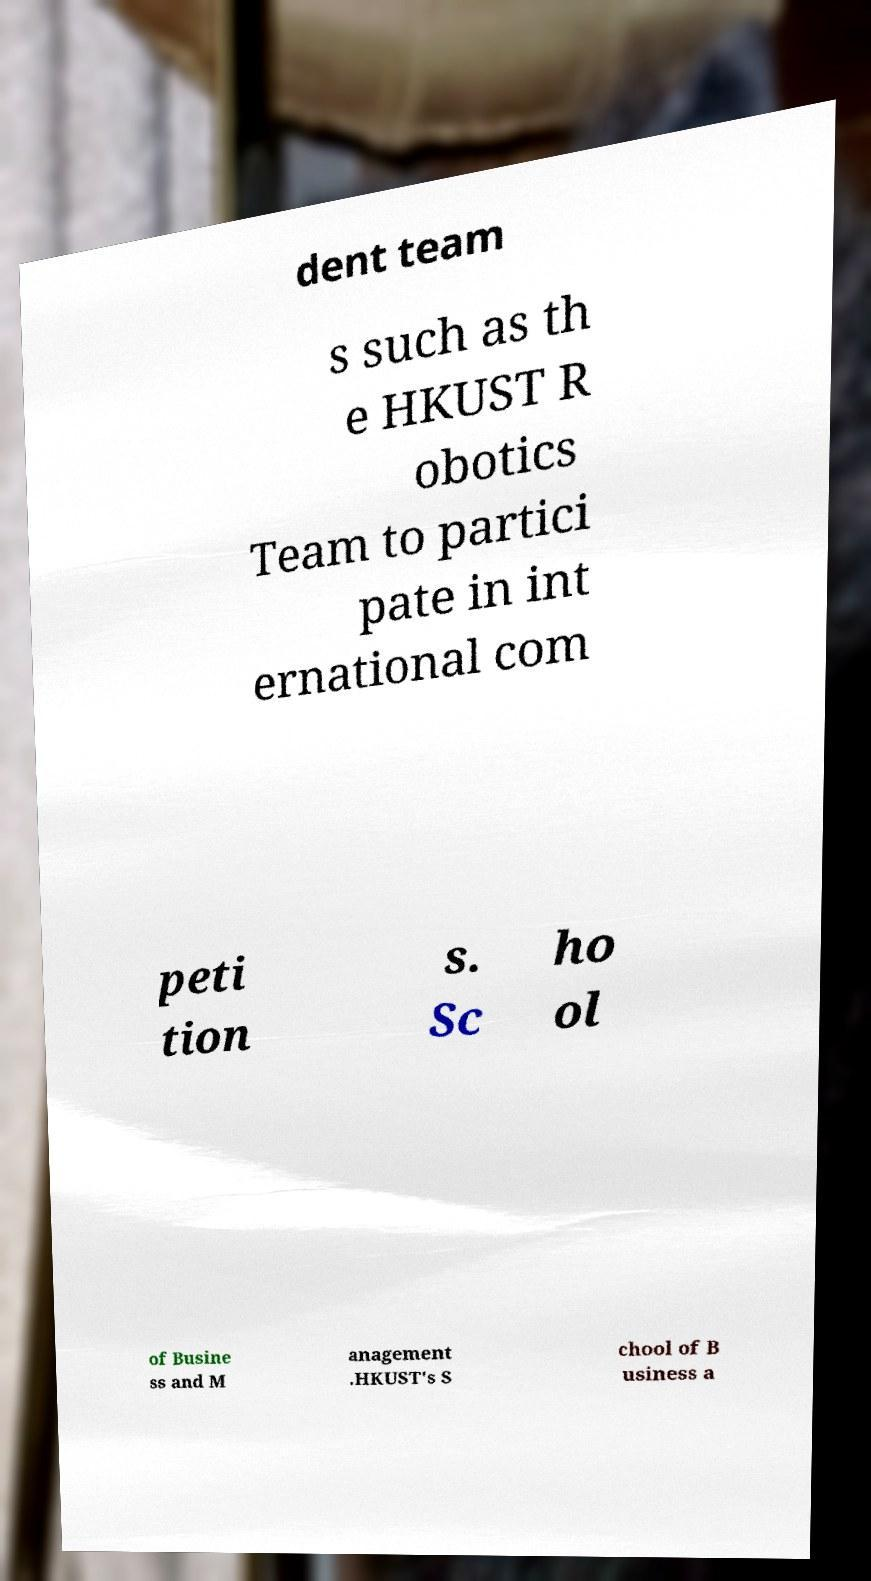Could you assist in decoding the text presented in this image and type it out clearly? dent team s such as th e HKUST R obotics Team to partici pate in int ernational com peti tion s. Sc ho ol of Busine ss and M anagement .HKUST's S chool of B usiness a 